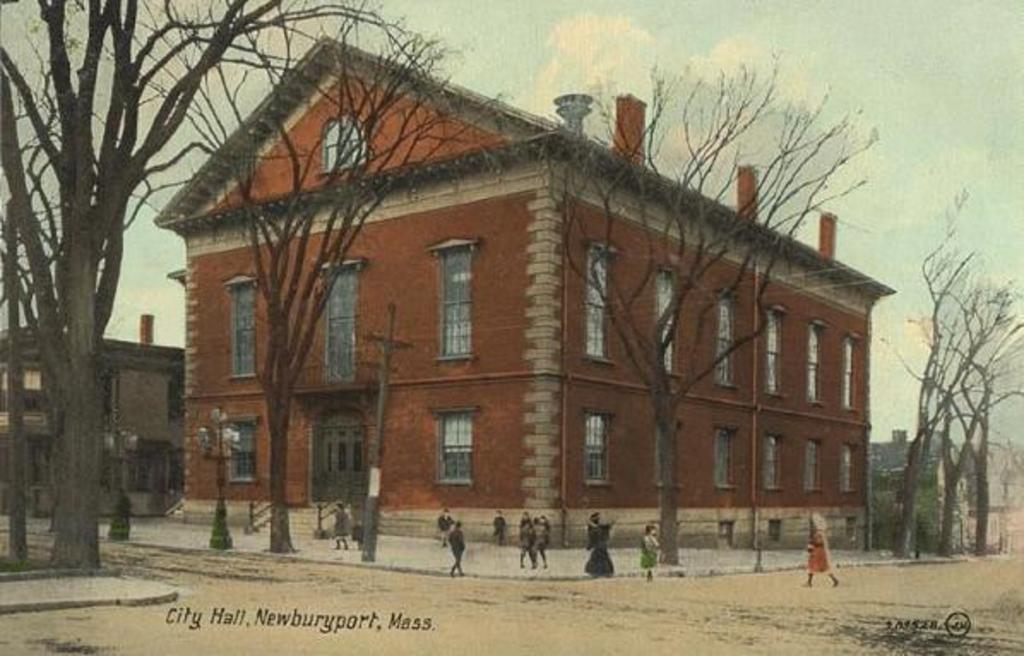What are the people in the image doing? The people in the image are standing on the road. What can be seen in the background of the image? There are buildings visible in the image. What type of vegetation is present in the image? There are trees in the image. What type of spark can be seen coming from the faucet in the image? There is no faucet present in the image, so it is not possible to determine if there is a spark or not. 